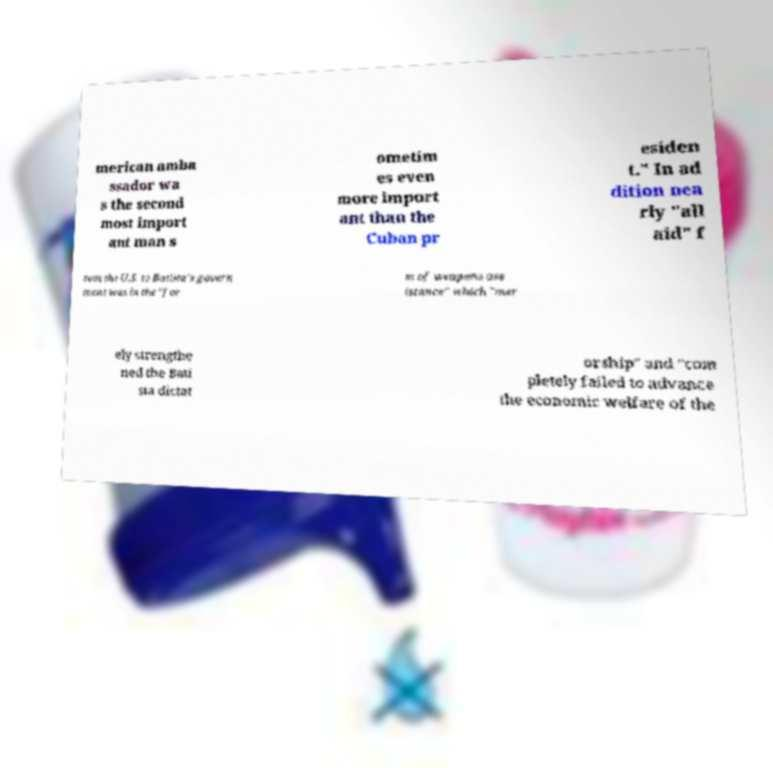For documentation purposes, I need the text within this image transcribed. Could you provide that? merican amba ssador wa s the second most import ant man s ometim es even more import ant than the Cuban pr esiden t." In ad dition nea rly "all aid" f rom the U.S. to Batista's govern ment was in the "for m of weapons ass istance" which "mer ely strengthe ned the Bati sta dictat orship" and "com pletely failed to advance the economic welfare of the 